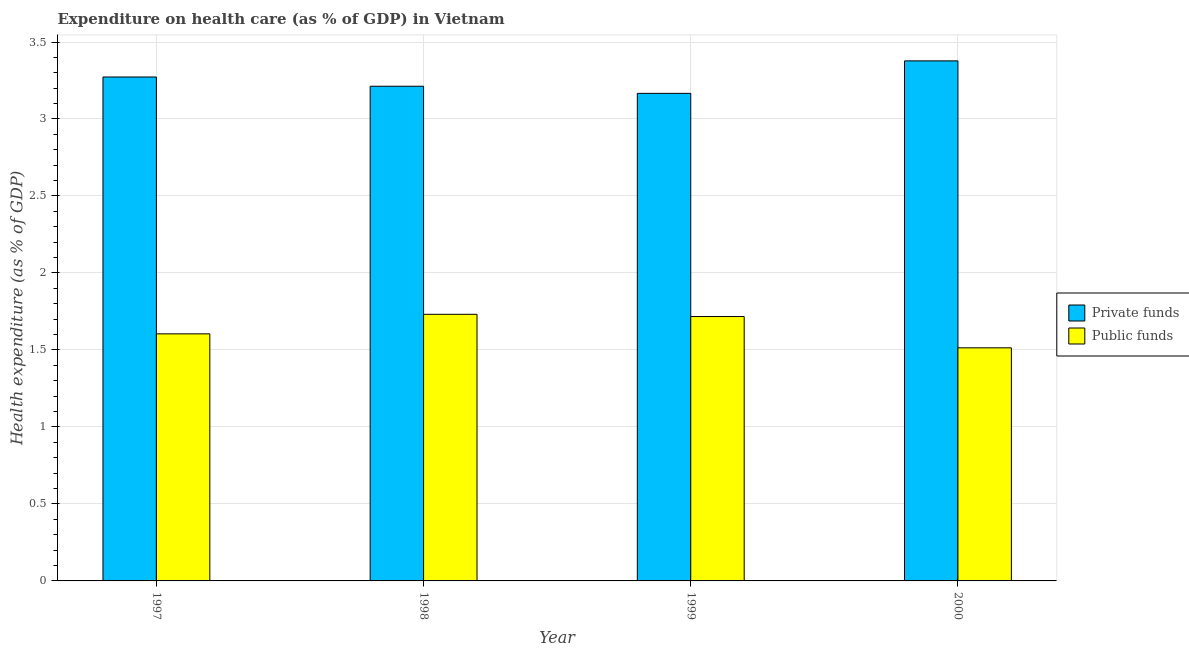How many different coloured bars are there?
Your answer should be compact. 2. Are the number of bars per tick equal to the number of legend labels?
Give a very brief answer. Yes. What is the label of the 1st group of bars from the left?
Your answer should be very brief. 1997. In how many cases, is the number of bars for a given year not equal to the number of legend labels?
Give a very brief answer. 0. What is the amount of private funds spent in healthcare in 2000?
Your answer should be very brief. 3.38. Across all years, what is the maximum amount of private funds spent in healthcare?
Make the answer very short. 3.38. Across all years, what is the minimum amount of public funds spent in healthcare?
Offer a very short reply. 1.51. In which year was the amount of private funds spent in healthcare maximum?
Provide a succinct answer. 2000. What is the total amount of public funds spent in healthcare in the graph?
Provide a short and direct response. 6.57. What is the difference between the amount of private funds spent in healthcare in 1999 and that in 2000?
Provide a succinct answer. -0.21. What is the difference between the amount of public funds spent in healthcare in 2000 and the amount of private funds spent in healthcare in 1998?
Provide a short and direct response. -0.22. What is the average amount of public funds spent in healthcare per year?
Offer a terse response. 1.64. In how many years, is the amount of public funds spent in healthcare greater than 1.2 %?
Provide a succinct answer. 4. What is the ratio of the amount of public funds spent in healthcare in 1997 to that in 2000?
Provide a succinct answer. 1.06. Is the amount of private funds spent in healthcare in 1997 less than that in 1998?
Your answer should be compact. No. What is the difference between the highest and the second highest amount of public funds spent in healthcare?
Give a very brief answer. 0.01. What is the difference between the highest and the lowest amount of private funds spent in healthcare?
Keep it short and to the point. 0.21. What does the 1st bar from the left in 1997 represents?
Your answer should be very brief. Private funds. What does the 1st bar from the right in 2000 represents?
Provide a short and direct response. Public funds. Are all the bars in the graph horizontal?
Ensure brevity in your answer.  No. What is the title of the graph?
Provide a succinct answer. Expenditure on health care (as % of GDP) in Vietnam. Does "Taxes on profits and capital gains" appear as one of the legend labels in the graph?
Offer a very short reply. No. What is the label or title of the X-axis?
Ensure brevity in your answer.  Year. What is the label or title of the Y-axis?
Provide a short and direct response. Health expenditure (as % of GDP). What is the Health expenditure (as % of GDP) in Private funds in 1997?
Ensure brevity in your answer.  3.27. What is the Health expenditure (as % of GDP) of Public funds in 1997?
Your answer should be very brief. 1.6. What is the Health expenditure (as % of GDP) of Private funds in 1998?
Ensure brevity in your answer.  3.21. What is the Health expenditure (as % of GDP) in Public funds in 1998?
Ensure brevity in your answer.  1.73. What is the Health expenditure (as % of GDP) in Private funds in 1999?
Ensure brevity in your answer.  3.17. What is the Health expenditure (as % of GDP) in Public funds in 1999?
Offer a very short reply. 1.72. What is the Health expenditure (as % of GDP) of Private funds in 2000?
Make the answer very short. 3.38. What is the Health expenditure (as % of GDP) of Public funds in 2000?
Give a very brief answer. 1.51. Across all years, what is the maximum Health expenditure (as % of GDP) in Private funds?
Provide a succinct answer. 3.38. Across all years, what is the maximum Health expenditure (as % of GDP) of Public funds?
Your answer should be compact. 1.73. Across all years, what is the minimum Health expenditure (as % of GDP) of Private funds?
Offer a terse response. 3.17. Across all years, what is the minimum Health expenditure (as % of GDP) of Public funds?
Ensure brevity in your answer.  1.51. What is the total Health expenditure (as % of GDP) in Private funds in the graph?
Provide a short and direct response. 13.03. What is the total Health expenditure (as % of GDP) of Public funds in the graph?
Your response must be concise. 6.57. What is the difference between the Health expenditure (as % of GDP) in Private funds in 1997 and that in 1998?
Give a very brief answer. 0.06. What is the difference between the Health expenditure (as % of GDP) of Public funds in 1997 and that in 1998?
Provide a short and direct response. -0.13. What is the difference between the Health expenditure (as % of GDP) in Private funds in 1997 and that in 1999?
Make the answer very short. 0.11. What is the difference between the Health expenditure (as % of GDP) in Public funds in 1997 and that in 1999?
Make the answer very short. -0.11. What is the difference between the Health expenditure (as % of GDP) of Private funds in 1997 and that in 2000?
Your response must be concise. -0.1. What is the difference between the Health expenditure (as % of GDP) of Public funds in 1997 and that in 2000?
Your answer should be very brief. 0.09. What is the difference between the Health expenditure (as % of GDP) of Private funds in 1998 and that in 1999?
Your answer should be very brief. 0.05. What is the difference between the Health expenditure (as % of GDP) in Public funds in 1998 and that in 1999?
Keep it short and to the point. 0.01. What is the difference between the Health expenditure (as % of GDP) in Private funds in 1998 and that in 2000?
Keep it short and to the point. -0.16. What is the difference between the Health expenditure (as % of GDP) in Public funds in 1998 and that in 2000?
Offer a very short reply. 0.22. What is the difference between the Health expenditure (as % of GDP) of Private funds in 1999 and that in 2000?
Offer a terse response. -0.21. What is the difference between the Health expenditure (as % of GDP) of Public funds in 1999 and that in 2000?
Provide a succinct answer. 0.2. What is the difference between the Health expenditure (as % of GDP) in Private funds in 1997 and the Health expenditure (as % of GDP) in Public funds in 1998?
Your response must be concise. 1.54. What is the difference between the Health expenditure (as % of GDP) of Private funds in 1997 and the Health expenditure (as % of GDP) of Public funds in 1999?
Give a very brief answer. 1.56. What is the difference between the Health expenditure (as % of GDP) in Private funds in 1997 and the Health expenditure (as % of GDP) in Public funds in 2000?
Make the answer very short. 1.76. What is the difference between the Health expenditure (as % of GDP) of Private funds in 1998 and the Health expenditure (as % of GDP) of Public funds in 1999?
Your response must be concise. 1.5. What is the difference between the Health expenditure (as % of GDP) in Private funds in 1998 and the Health expenditure (as % of GDP) in Public funds in 2000?
Offer a very short reply. 1.7. What is the difference between the Health expenditure (as % of GDP) of Private funds in 1999 and the Health expenditure (as % of GDP) of Public funds in 2000?
Make the answer very short. 1.65. What is the average Health expenditure (as % of GDP) in Private funds per year?
Your response must be concise. 3.26. What is the average Health expenditure (as % of GDP) in Public funds per year?
Ensure brevity in your answer.  1.64. In the year 1997, what is the difference between the Health expenditure (as % of GDP) in Private funds and Health expenditure (as % of GDP) in Public funds?
Your response must be concise. 1.67. In the year 1998, what is the difference between the Health expenditure (as % of GDP) of Private funds and Health expenditure (as % of GDP) of Public funds?
Your answer should be compact. 1.48. In the year 1999, what is the difference between the Health expenditure (as % of GDP) in Private funds and Health expenditure (as % of GDP) in Public funds?
Provide a succinct answer. 1.45. In the year 2000, what is the difference between the Health expenditure (as % of GDP) in Private funds and Health expenditure (as % of GDP) in Public funds?
Make the answer very short. 1.86. What is the ratio of the Health expenditure (as % of GDP) in Private funds in 1997 to that in 1998?
Your response must be concise. 1.02. What is the ratio of the Health expenditure (as % of GDP) in Public funds in 1997 to that in 1998?
Make the answer very short. 0.93. What is the ratio of the Health expenditure (as % of GDP) in Private funds in 1997 to that in 1999?
Give a very brief answer. 1.03. What is the ratio of the Health expenditure (as % of GDP) in Public funds in 1997 to that in 1999?
Give a very brief answer. 0.93. What is the ratio of the Health expenditure (as % of GDP) in Public funds in 1997 to that in 2000?
Offer a terse response. 1.06. What is the ratio of the Health expenditure (as % of GDP) of Private funds in 1998 to that in 1999?
Give a very brief answer. 1.01. What is the ratio of the Health expenditure (as % of GDP) of Public funds in 1998 to that in 1999?
Your answer should be compact. 1.01. What is the ratio of the Health expenditure (as % of GDP) of Private funds in 1998 to that in 2000?
Ensure brevity in your answer.  0.95. What is the ratio of the Health expenditure (as % of GDP) in Public funds in 1998 to that in 2000?
Provide a succinct answer. 1.14. What is the ratio of the Health expenditure (as % of GDP) in Private funds in 1999 to that in 2000?
Provide a succinct answer. 0.94. What is the ratio of the Health expenditure (as % of GDP) in Public funds in 1999 to that in 2000?
Offer a terse response. 1.13. What is the difference between the highest and the second highest Health expenditure (as % of GDP) in Private funds?
Ensure brevity in your answer.  0.1. What is the difference between the highest and the second highest Health expenditure (as % of GDP) in Public funds?
Make the answer very short. 0.01. What is the difference between the highest and the lowest Health expenditure (as % of GDP) of Private funds?
Give a very brief answer. 0.21. What is the difference between the highest and the lowest Health expenditure (as % of GDP) in Public funds?
Provide a succinct answer. 0.22. 